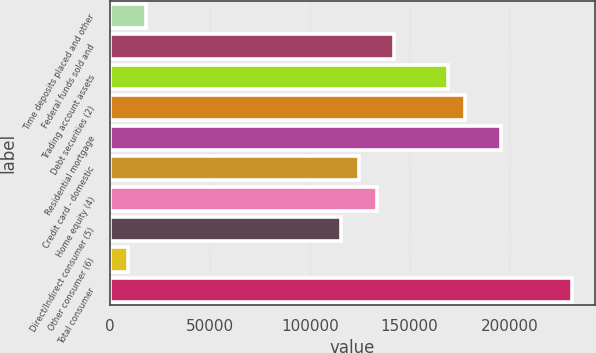Convert chart to OTSL. <chart><loc_0><loc_0><loc_500><loc_500><bar_chart><fcel>Time deposits placed and other<fcel>Federal funds sold and<fcel>Trading account assets<fcel>Debt securities (2)<fcel>Residential mortgage<fcel>Credit card - domestic<fcel>Home equity (4)<fcel>Direct/Indirect consumer (5)<fcel>Other consumer (6)<fcel>Total consumer<nl><fcel>17961<fcel>142372<fcel>169032<fcel>177918<fcel>195691<fcel>124599<fcel>133486<fcel>115712<fcel>9074.5<fcel>231237<nl></chart> 